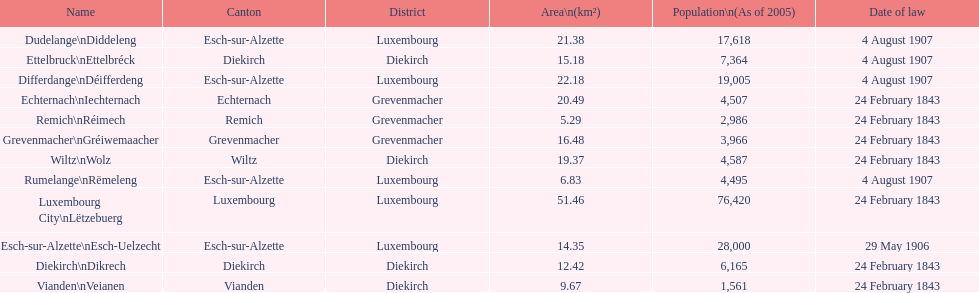Parse the full table. {'header': ['Name', 'Canton', 'District', 'Area\\n(km²)', 'Population\\n(As of 2005)', 'Date of law'], 'rows': [['Dudelange\\nDiddeleng', 'Esch-sur-Alzette', 'Luxembourg', '21.38', '17,618', '4 August 1907'], ['Ettelbruck\\nEttelbréck', 'Diekirch', 'Diekirch', '15.18', '7,364', '4 August 1907'], ['Differdange\\nDéifferdeng', 'Esch-sur-Alzette', 'Luxembourg', '22.18', '19,005', '4 August 1907'], ['Echternach\\nIechternach', 'Echternach', 'Grevenmacher', '20.49', '4,507', '24 February 1843'], ['Remich\\nRéimech', 'Remich', 'Grevenmacher', '5.29', '2,986', '24 February 1843'], ['Grevenmacher\\nGréiwemaacher', 'Grevenmacher', 'Grevenmacher', '16.48', '3,966', '24 February 1843'], ['Wiltz\\nWolz', 'Wiltz', 'Diekirch', '19.37', '4,587', '24 February 1843'], ['Rumelange\\nRëmeleng', 'Esch-sur-Alzette', 'Luxembourg', '6.83', '4,495', '4 August 1907'], ['Luxembourg City\\nLëtzebuerg', 'Luxembourg', 'Luxembourg', '51.46', '76,420', '24 February 1843'], ['Esch-sur-Alzette\\nEsch-Uelzecht', 'Esch-sur-Alzette', 'Luxembourg', '14.35', '28,000', '29 May 1906'], ['Diekirch\\nDikrech', 'Diekirch', 'Diekirch', '12.42', '6,165', '24 February 1843'], ['Vianden\\nVeianen', 'Vianden', 'Diekirch', '9.67', '1,561', '24 February 1843']]} How many diekirch districts also have diekirch as their canton? 2. 